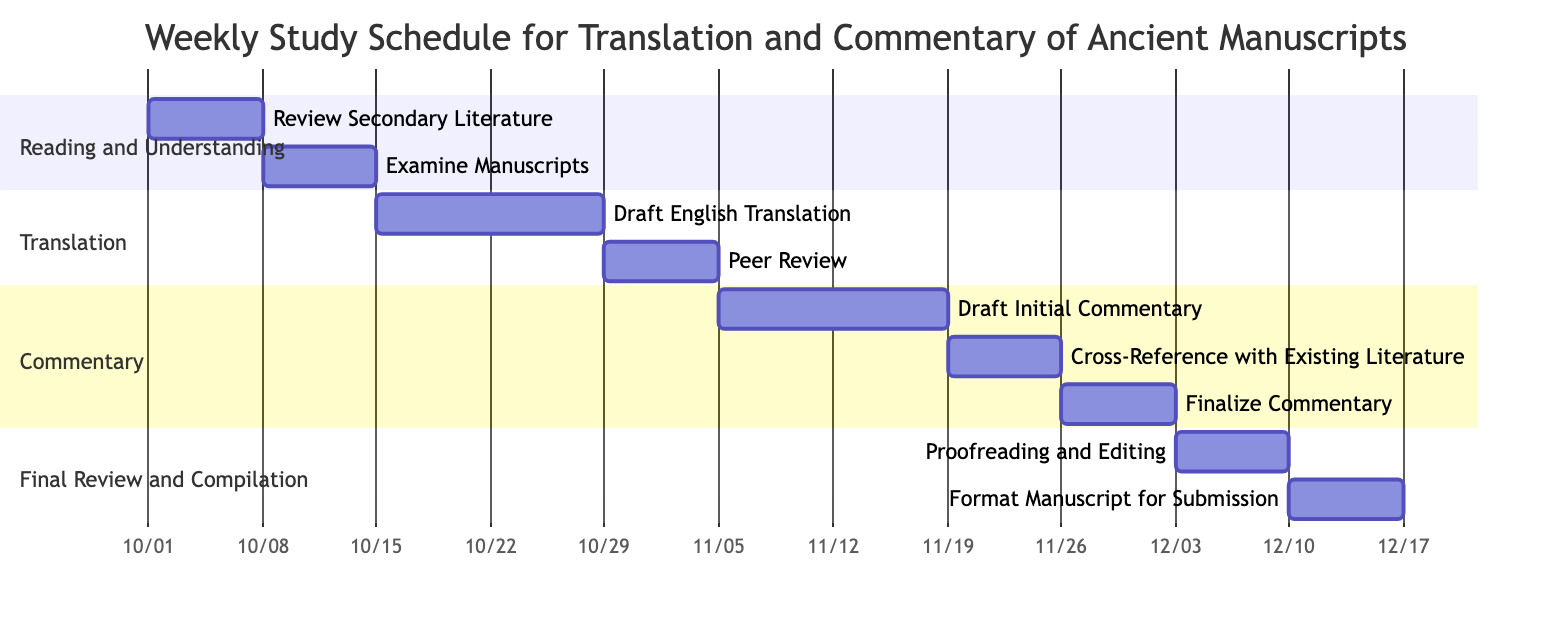What are the start and end dates for the "Examine Manuscripts" task? The task "Examine Manuscripts" starts on "2023-10-08" and ends on "2023-10-14." These dates are clearly indicated next to the task in the Reading and Understanding section of the Gantt Chart.
Answer: 2023-10-08 to 2023-10-14 How long is the "Draft Initial Commentary" phase? The "Draft Initial Commentary" phase starts on "2023-11-05" and ends on "2023-11-18." To calculate the duration, we find the difference between the end and the start date, which is 14 days.
Answer: 14 days Which task follows "Peer Review"? The task that follows "Peer Review" is "Draft Initial Commentary." In the Gantt Chart, tasks are sequenced, and this task begins immediately after the Peer Review period ends.
Answer: Draft Initial Commentary What is the total number of tasks in the "Commentary" section? The Commentary section contains three tasks: "Draft Initial Commentary," "Cross-Reference with Existing Literature," and "Finalize Commentary." Counting these gives us a total of three tasks.
Answer: 3 During which weeks does "Proofreading and Editing" occur? "Proofreading and Editing" takes place from "2023-12-03" to "2023-12-09." This period spans one week, beginning on Sunday and ending on the following Saturday.
Answer: December 3 to December 9 What is the duration of the entire study schedule represented in the Gantt Chart? The entire study schedule starts on "2023-10-01" with the first task and ends on "2023-12-16" with the final task of formatting the manuscript for submission. The total duration can be calculated by counting all the days from the start to the end date, resulting in 76 days.
Answer: 76 days Which section has the most tasks? The section with the most tasks is "Commentary," which has three tasks: "Draft Initial Commentary," "Cross-Reference with Existing Literature," and "Finalize Commentary." This is more than the other sections, which have fewer tasks.
Answer: Commentary What is the last task in the schedule? The last task in the schedule is "Format Manuscript for Submission," which occurs from "2023-12-10" to "2023-12-16." This task is positioned at the end of the Final Review and Compilation section.
Answer: Format Manuscript for Submission 